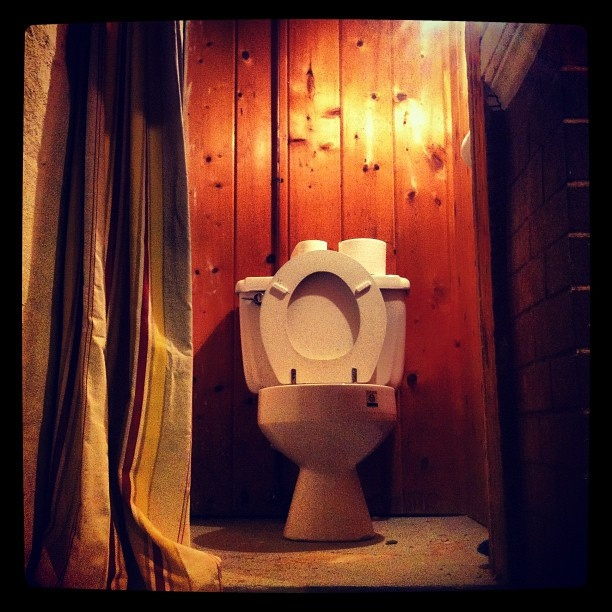Describe the objects in this image and their specific colors. I can see a toilet in black, maroon, tan, and brown tones in this image. 